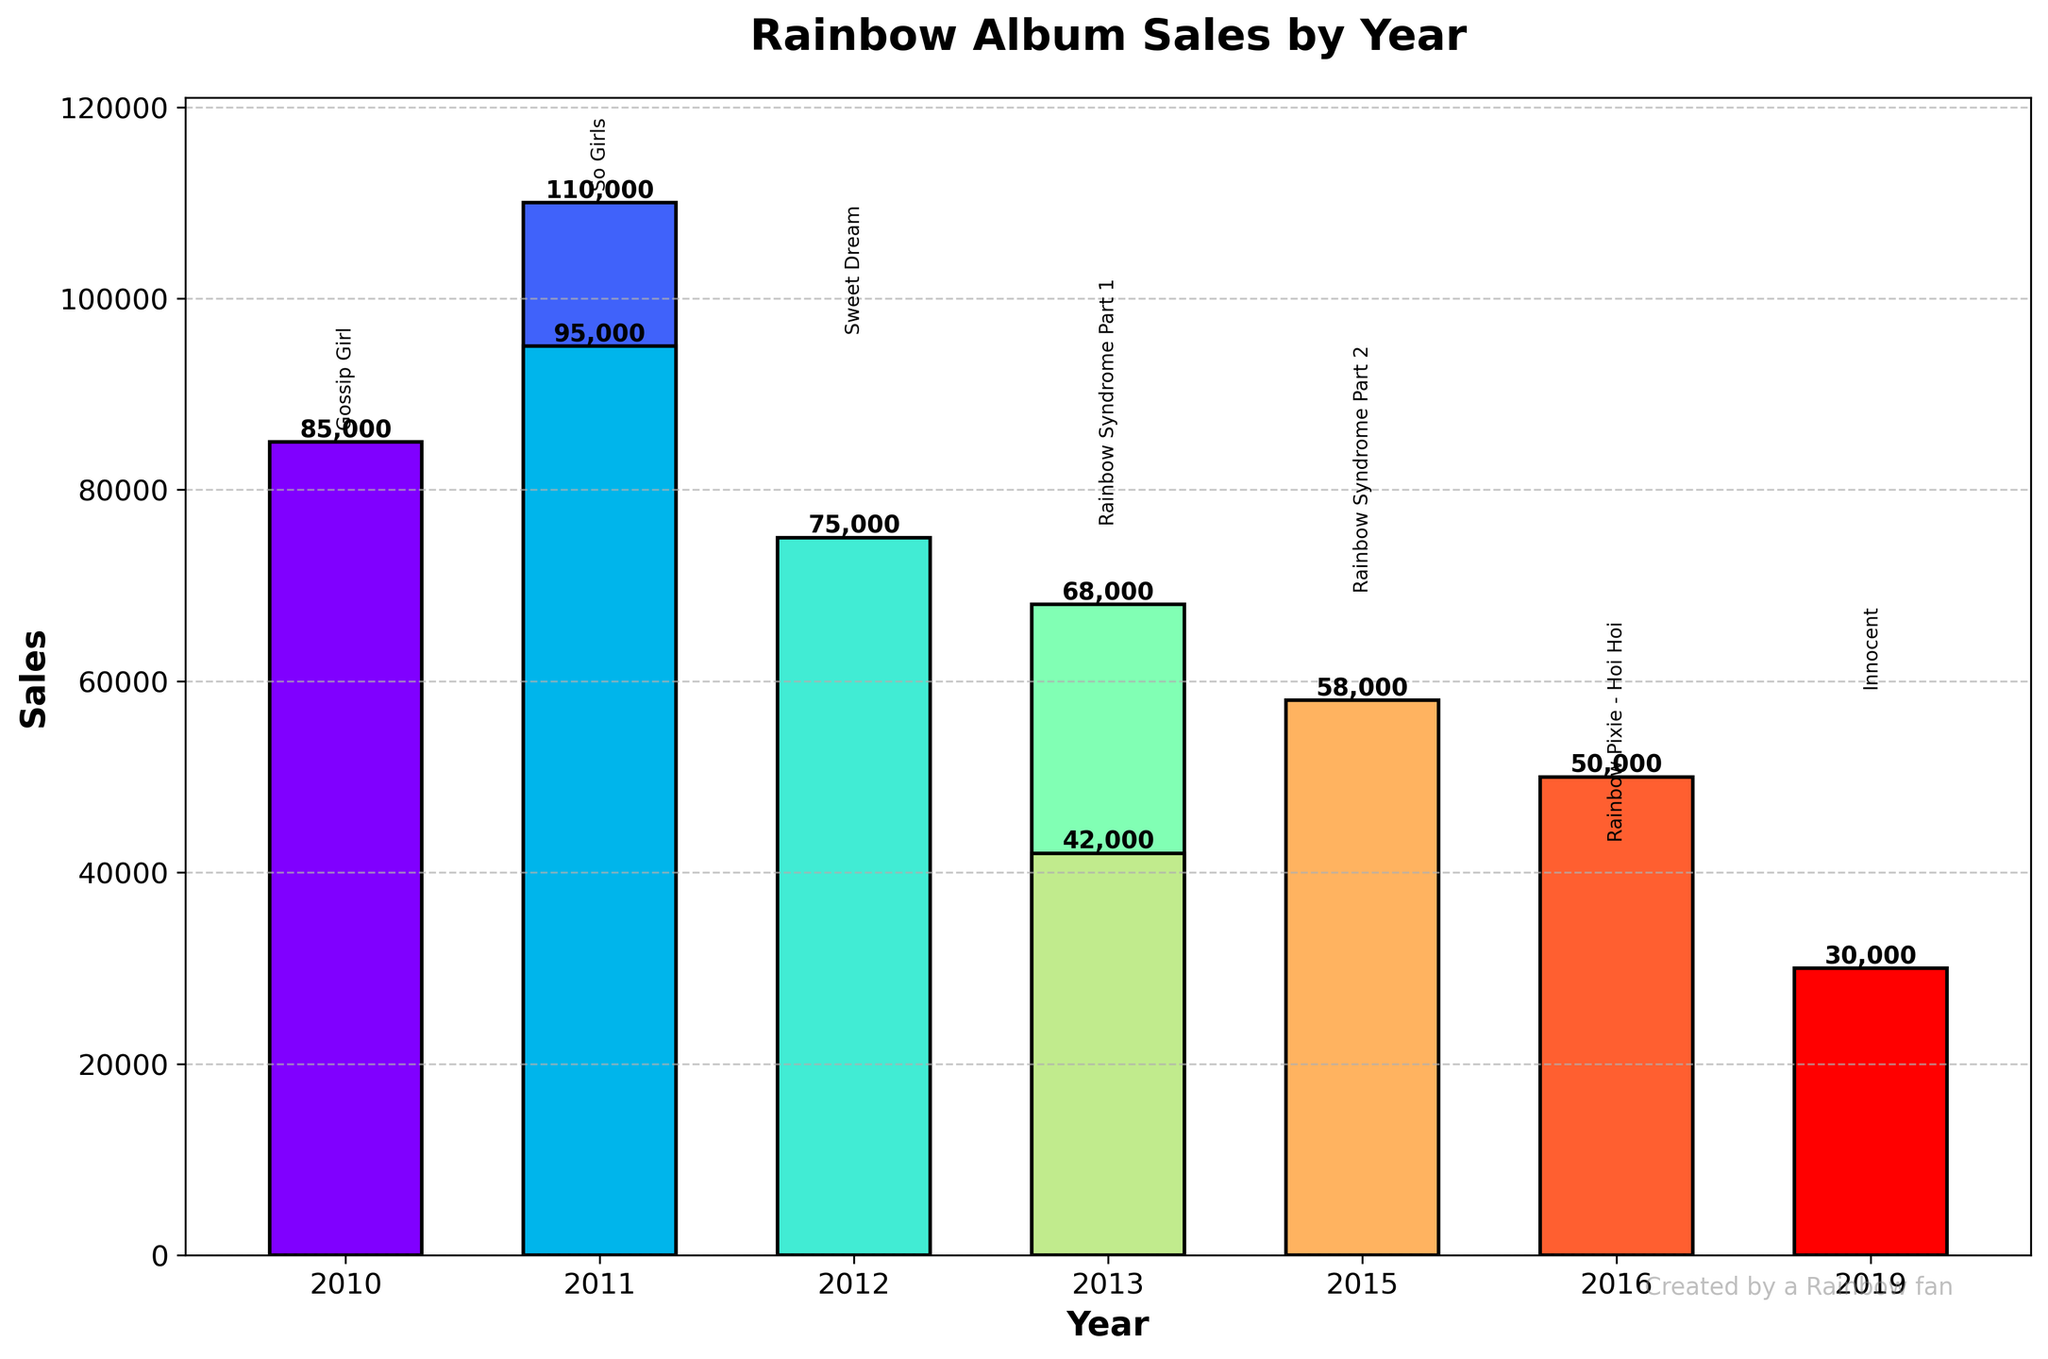What year had the highest album sales? The bar with the highest height indicates the year with the highest album sales. According to the figure, the year 2011 shows the tallest bar with 110,000 sales (album "So Girls").
Answer: 2011 Which album had the lowest sales, and what were the sales figures? The smallest bar represents the album with the lowest sales. The bar indicating "Over the Rainbow" in 2019 is the shortest, having sales of 30,000 units.
Answer: Over the Rainbow, 30,000 What is the total album sales for albums released in 2011? To find the total sales for albums released in 2011, add the sales of "So Girls" (110,000) and "Sweet Dream" (95,000). So the total is 110,000 + 95,000 = 205,000.
Answer: 205,000 Compare the sales of "Innocent" (2015) and "Prism" (2016). Which album sold more and by how much? The bar representing "Innocent" shows 58,000 sales, while "Prism" has 50,000 sales. Subtracting 50,000 from 58,000 gives 8,000, indicating "Innocent" sold 8,000 more than "Prism".
Answer: Innocent, by 8,000 Which year saw the largest decline in sales compared to the previous album release, and what was the difference in sales? Compare the sales from each year to its preceding year. The largest decline is between 2011 ("Sweet Dream" with 95,000 sales) and 2012 ("Rainbow Syndrome Part 1" with 75,000 sales). The decline is 95,000 - 75,000 = 20,000.
Answer: 2012, 20,000 What is the average sales figure across all the albums? Sum up all the album sales and divide by the number of albums. Total sales is 85,000 + 110,000 + 95,000 + 75,000 + 68,000 + 42,000 + 58,000 + 50,000 + 30,000 = 613,000. There are 9 albums, so the average is 613,000 / 9 ≈ 68,111.
Answer: 68,111 How many albums sold more than 70,000 units? Identify bars taller than the 70,000 sales mark. The albums "Gossip Girl" (85,000), "So Girls" (110,000), "Sweet Dream" (95,000) and "Rainbow Syndrome Part 1" (75,000) all exceed 70,000. There are 4 such albums.
Answer: 4 During which year did Rainbow release the largest number of albums, and how many did they release? Check the years in the figure for multiple albums. The year 2011 has two albums, "So Girls" and "Sweet Dream", making it the year with the most releases.
Answer: 2011, 2 By how much did the sales of "Rainbow Pixie - Hoi Hoi" (2013) fall short of "Rainbow Syndrome Part 2" (2013)? Sales of "Rainbow Pixie - Hoi Hoi" are 42,000, while "Rainbow Syndrome Part 2" are 68,000. The difference is 68,000 - 42,000 = 26,000.
Answer: 26,000 